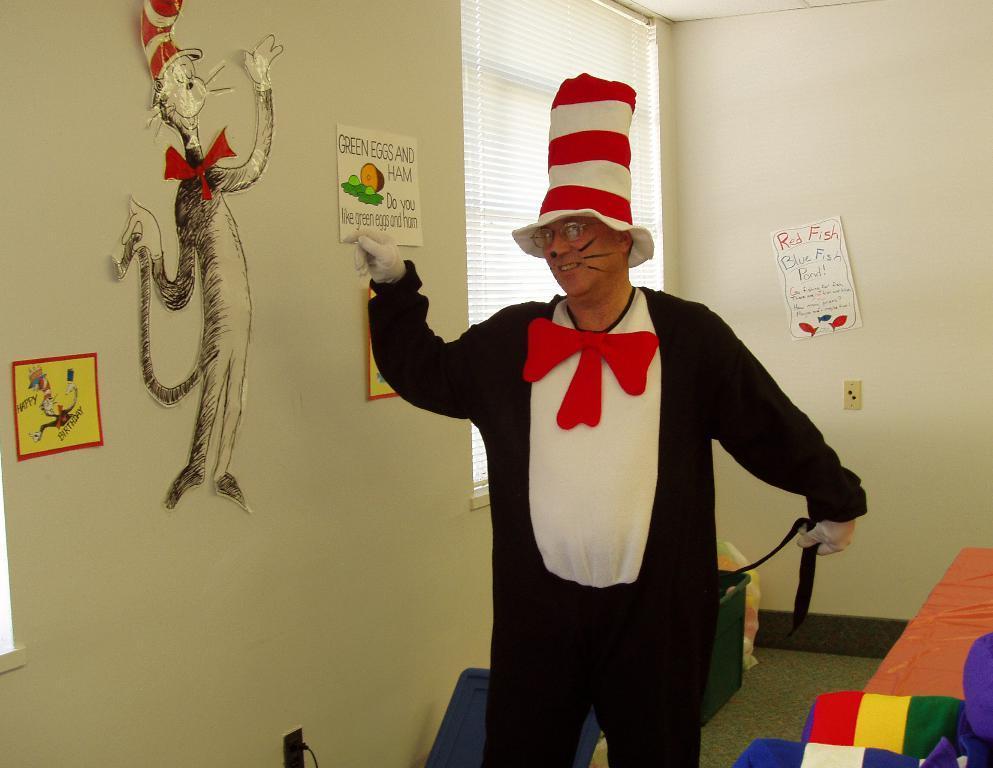In one or two sentences, can you explain what this image depicts? This is an inside view of a room. In the middle of the image there is a man wearing a costume, standing, smiling and giving pose for the picture. On the right side there are few objects placed on the ground. On the left side there are few posts attached to the wall. At the back of this man there is a window. 